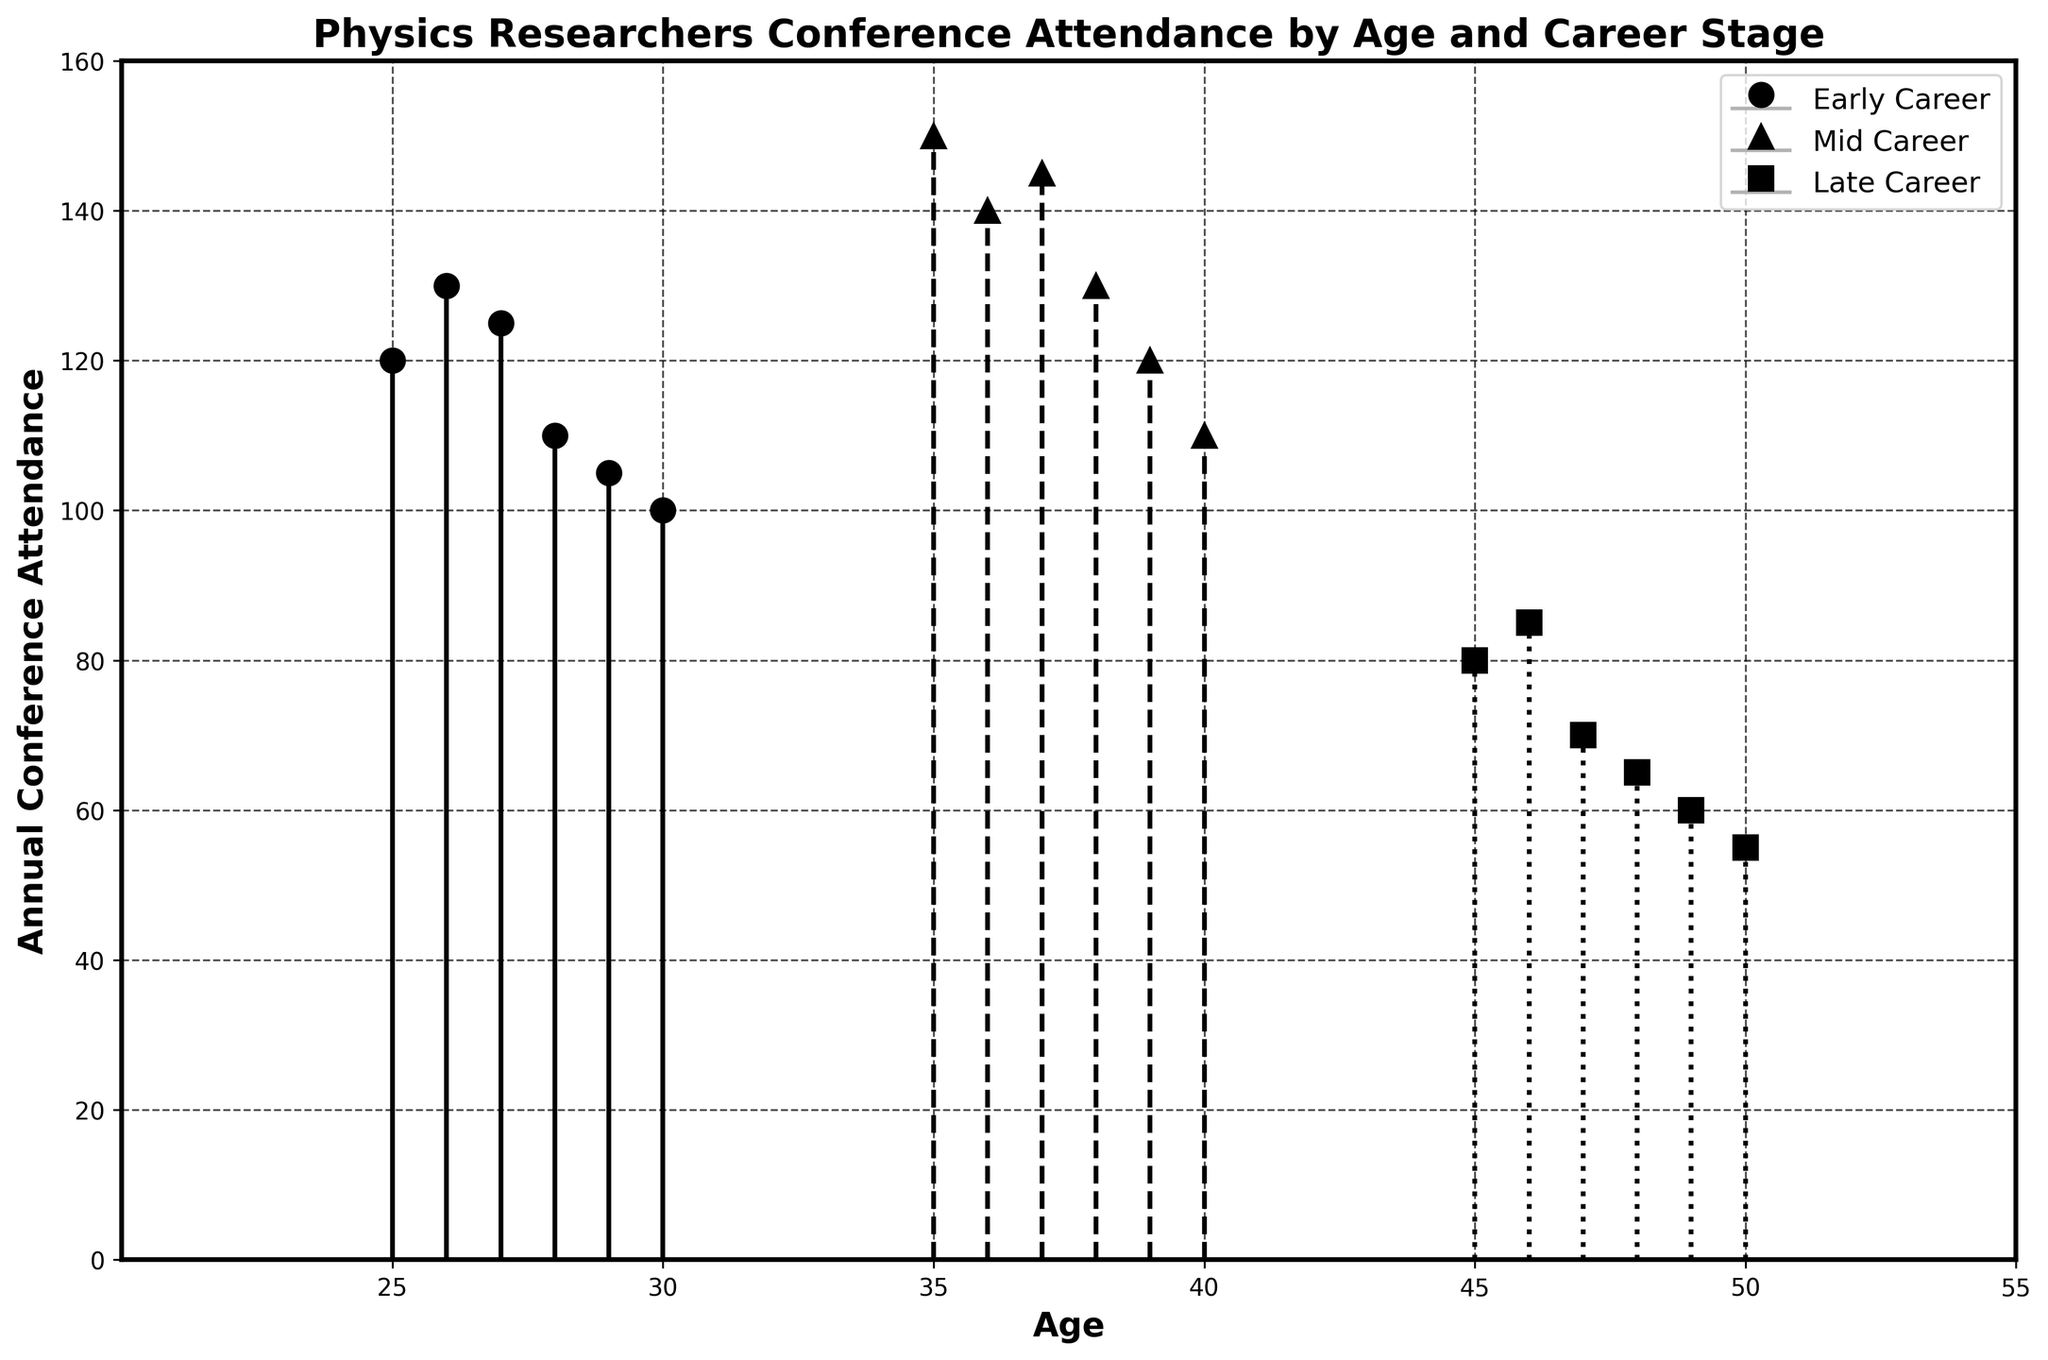What is the title of the figure? The title of the figure is written at the top and summarizes what the figure represents.
Answer: Physics Researchers Conference Attendance by Age and Career Stage What is the annual conference attendance for mid-career researchers aged 36? Find the marker representing mid-career researchers at age 36 and read its y-value.
Answer: 140 Which career stage has the highest peak attendance, and what is the value? Compare the peaks for Early Career, Mid Career, and Late Career.
Answer: Early Career with 130 At what ages is the conference attendance for late-career researchers measured? Identify the ages on the x-axis corresponding to late-career markers.
Answer: 45 to 50 What is the average conference attendance of early-career researchers between ages 25 and 30? Sum the attendance values for early-career researchers from ages 25 to 30 and divide by the number of data points. (120 + 130 + 125 + 110 + 105 + 100) / 6 = 690 / 6 = 115
Answer: 115 How does the conference attendance trend for mid-career researchers change from ages 35 to 40? Read the attendance values for each age in the range and describe the trend. Mid Career: 150 at 35, 140 at 36, 145 at 37, 130 at 38, 120 at 39, and 110 at 40.
Answer: Decreasing How many distinct ages are represented in the stem plot for all career stages combined? Count the unique ages on the x-axis that have corresponding markers for any career stage. Ages: 25, 26, 27, 28, 29, 30, 35, 36, 37, 38, 39, 40, 45, 46, 47, 48, 49, 50.
Answer: 18 Comparing early-career and late-career conference attendance, which stage has a lower overall trend? Look at the general trend lines for both early-career and late-career stages and determine which is lower. Early Career decreases from 130 to 100, while Late Career decreases from 80 to 55.
Answer: Late Career 